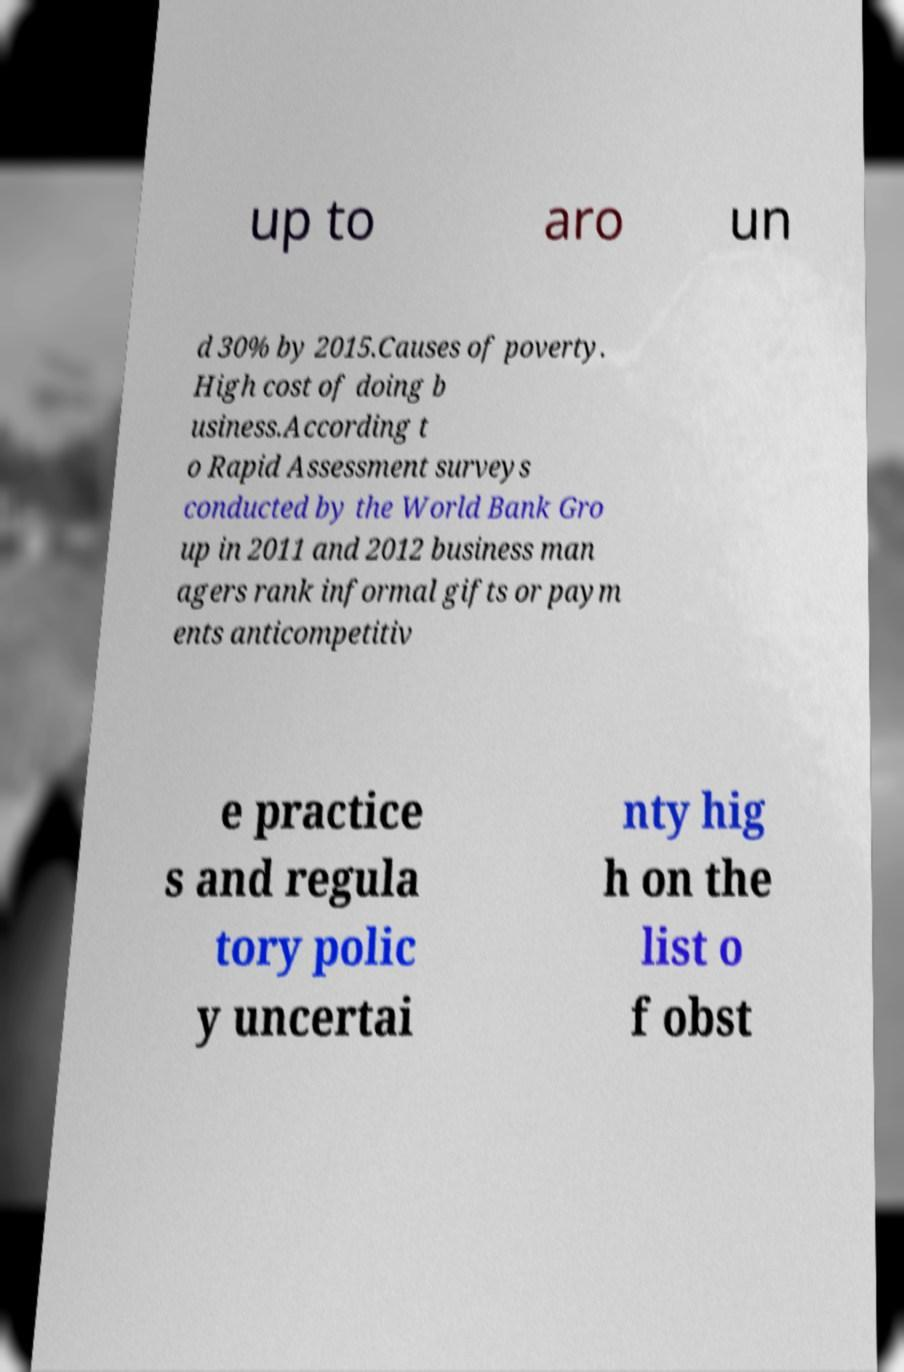Could you extract and type out the text from this image? up to aro un d 30% by 2015.Causes of poverty. High cost of doing b usiness.According t o Rapid Assessment surveys conducted by the World Bank Gro up in 2011 and 2012 business man agers rank informal gifts or paym ents anticompetitiv e practice s and regula tory polic y uncertai nty hig h on the list o f obst 